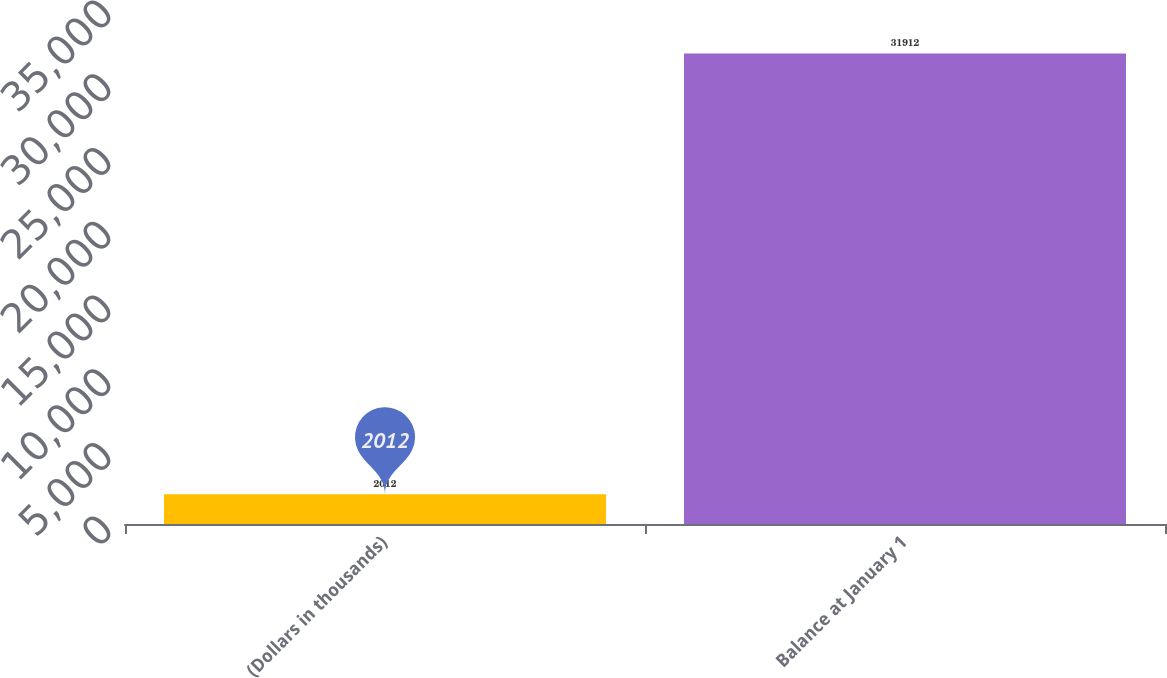Convert chart to OTSL. <chart><loc_0><loc_0><loc_500><loc_500><bar_chart><fcel>(Dollars in thousands)<fcel>Balance at January 1<nl><fcel>2012<fcel>31912<nl></chart> 